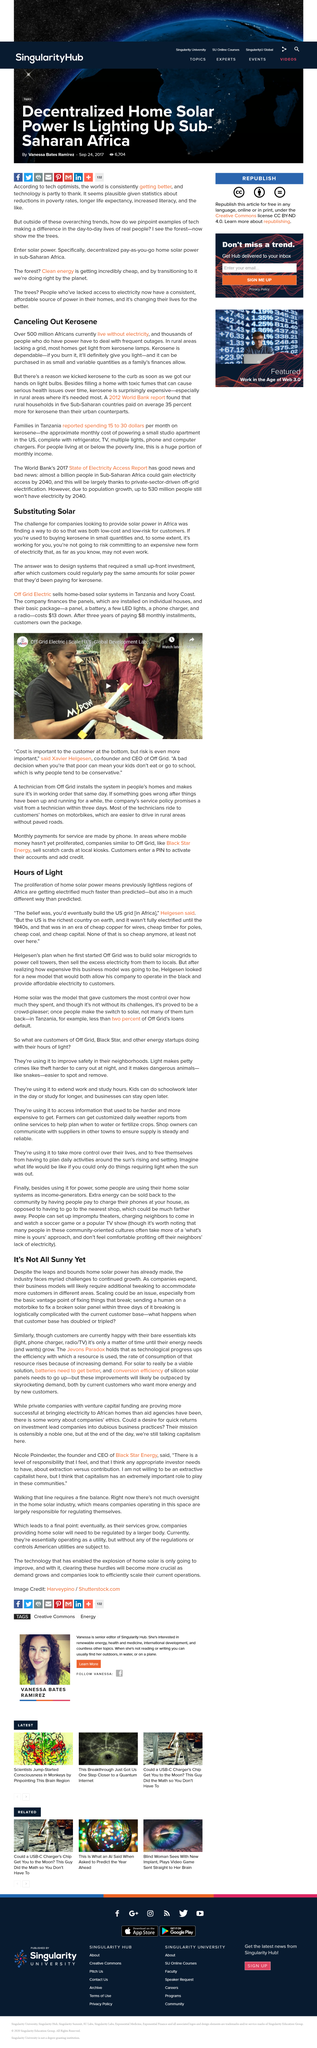Highlight a few significant elements in this photo. The expediting of the electrification process in Africa is being driven by solar power, which is a type of renewable energy. Off Grid Electric is a company that sells home-based solar systems in Tanzania and Ivory Coast. The title of the embedded video is Off-Grid Electric Scale U.S. Global Development Lab and it is shareable. In areas without access to a grid, the primary source of light is Kerosene lamps, particularly in rural areas. Over 500 million Africans currently live without access to electricity, according to recent estimates. 